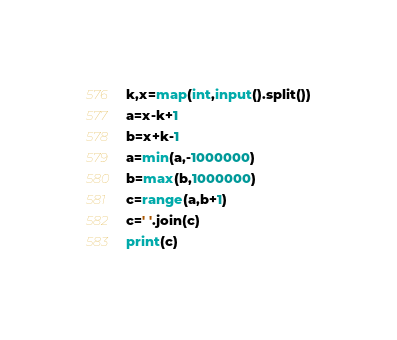Convert code to text. <code><loc_0><loc_0><loc_500><loc_500><_Python_>k,x=map(int,input().split())
a=x-k+1
b=x+k-1
a=min(a,-1000000)
b=max(b,1000000)
c=range(a,b+1)
c=' '.join(c)
print(c)
</code> 